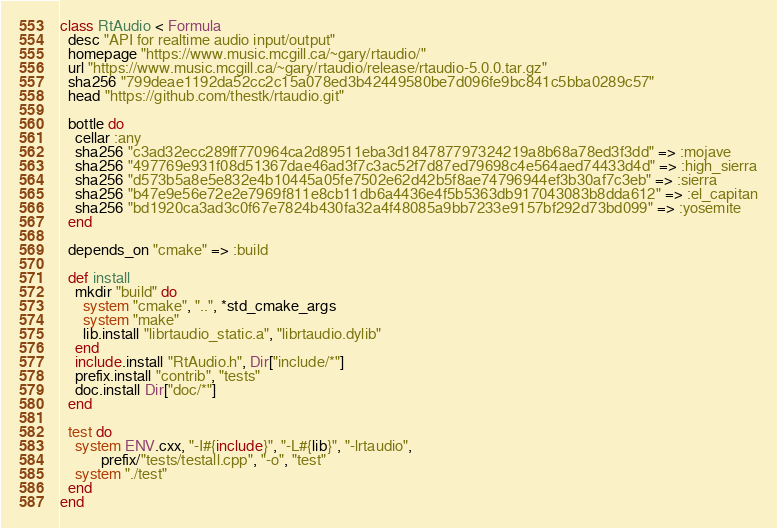<code> <loc_0><loc_0><loc_500><loc_500><_Ruby_>class RtAudio < Formula
  desc "API for realtime audio input/output"
  homepage "https://www.music.mcgill.ca/~gary/rtaudio/"
  url "https://www.music.mcgill.ca/~gary/rtaudio/release/rtaudio-5.0.0.tar.gz"
  sha256 "799deae1192da52cc2c15a078ed3b42449580be7d096fe9bc841c5bba0289c57"
  head "https://github.com/thestk/rtaudio.git"

  bottle do
    cellar :any
    sha256 "c3ad32ecc289ff770964ca2d89511eba3d184787797324219a8b68a78ed3f3dd" => :mojave
    sha256 "497769e931f08d51367dae46ad3f7c3ac52f7d87ed79698c4e564aed74433d4d" => :high_sierra
    sha256 "d573b5a8e5e832e4b10445a05fe7502e62d42b5f8ae74796944ef3b30af7c3eb" => :sierra
    sha256 "b47e9e56e72e2e7969f811e8cb11db6a4436e4f5b5363db917043083b8dda612" => :el_capitan
    sha256 "bd1920ca3ad3c0f67e7824b430fa32a4f48085a9bb7233e9157bf292d73bd099" => :yosemite
  end

  depends_on "cmake" => :build

  def install
    mkdir "build" do
      system "cmake", "..", *std_cmake_args
      system "make"
      lib.install "librtaudio_static.a", "librtaudio.dylib"
    end
    include.install "RtAudio.h", Dir["include/*"]
    prefix.install "contrib", "tests"
    doc.install Dir["doc/*"]
  end

  test do
    system ENV.cxx, "-I#{include}", "-L#{lib}", "-lrtaudio",
           prefix/"tests/testall.cpp", "-o", "test"
    system "./test"
  end
end
</code> 